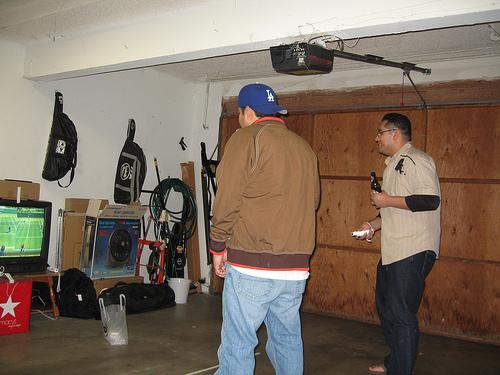What is the man holding in addition to the Wii controller? The man is also holding a beer bottle. Identify the color and type of hat the man is wearing. The man is wearing a blue and white baseball cap. How many people are present in the image? There are two men standing in front of the TV. Describe an object hanging on the wall in the image. There is a bag hanging on the wall. List three objects on the ground in the image. A clear plastic bag, a Macy bag, and a red and white bag are on the ground. What color is the garage door in the background, and what is its material? The garage door in the background is wooden and painted white. Where is the TV placed in relation to other objects? The TV is sitting on a table or chair, with a clear plastic bag in front of it. What type of controller is the man holding, and what is he doing with it? The man is holding a white Wii controller and pointing it at the TV. Mention the type and color of the jacket the man is wearing. The man is wearing a brown and orange jacket. What is the object near the garage door apparatus? A white bucket is in the corner near the garage door apparatus. 